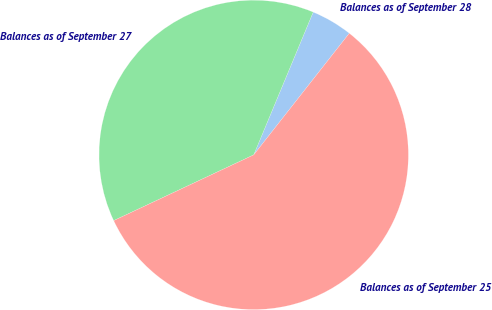Convert chart to OTSL. <chart><loc_0><loc_0><loc_500><loc_500><pie_chart><fcel>Balances as of September 28<fcel>Balances as of September 27<fcel>Balances as of September 25<nl><fcel>4.32%<fcel>38.27%<fcel>57.41%<nl></chart> 